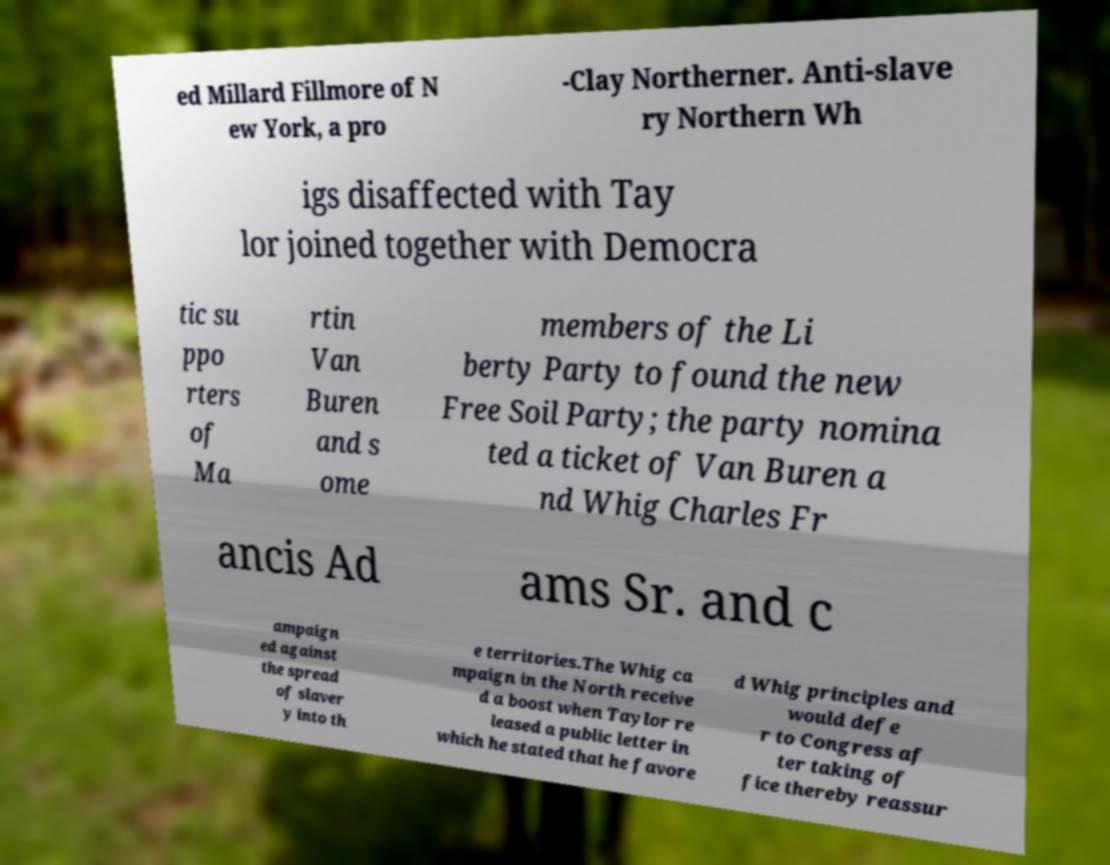I need the written content from this picture converted into text. Can you do that? ed Millard Fillmore of N ew York, a pro -Clay Northerner. Anti-slave ry Northern Wh igs disaffected with Tay lor joined together with Democra tic su ppo rters of Ma rtin Van Buren and s ome members of the Li berty Party to found the new Free Soil Party; the party nomina ted a ticket of Van Buren a nd Whig Charles Fr ancis Ad ams Sr. and c ampaign ed against the spread of slaver y into th e territories.The Whig ca mpaign in the North receive d a boost when Taylor re leased a public letter in which he stated that he favore d Whig principles and would defe r to Congress af ter taking of fice thereby reassur 